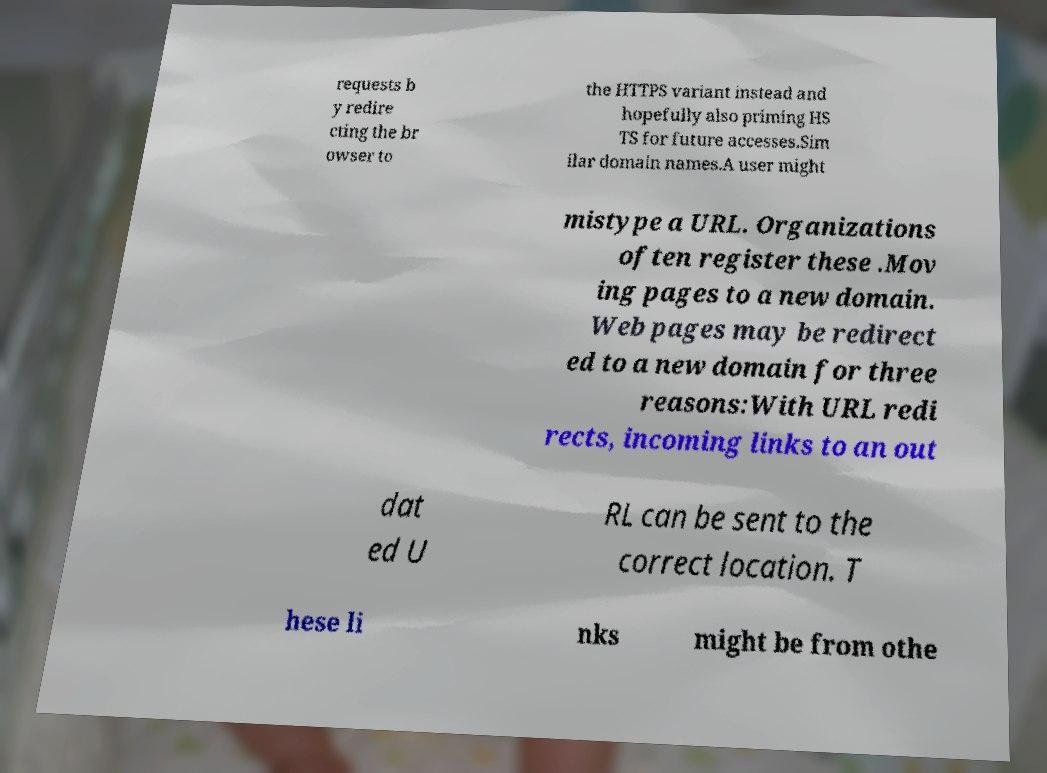Could you assist in decoding the text presented in this image and type it out clearly? requests b y redire cting the br owser to the HTTPS variant instead and hopefully also priming HS TS for future accesses.Sim ilar domain names.A user might mistype a URL. Organizations often register these .Mov ing pages to a new domain. Web pages may be redirect ed to a new domain for three reasons:With URL redi rects, incoming links to an out dat ed U RL can be sent to the correct location. T hese li nks might be from othe 